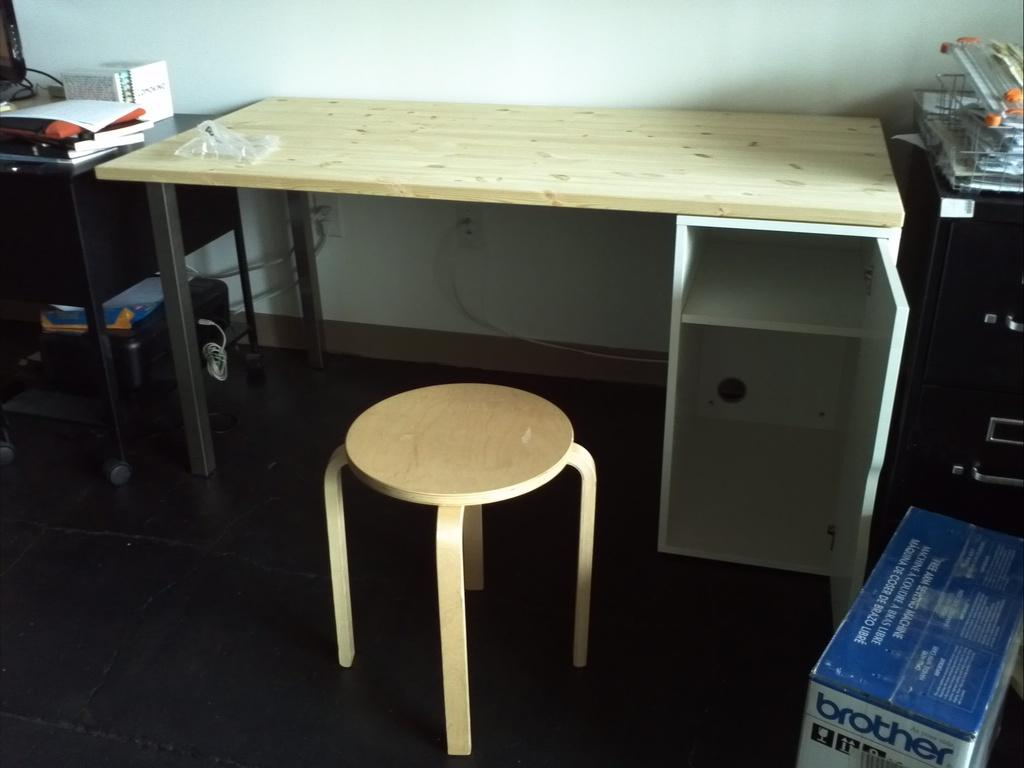<image>
Summarize the visual content of the image. A wooden desk and stool in a cluttered room with a box that says brother. 